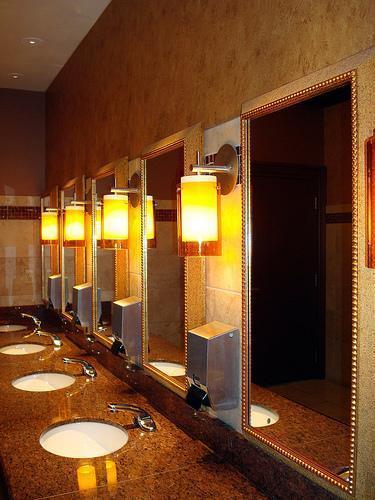How many mirrors are pictured?
Give a very brief answer. 5. How many people are in the picture?
Give a very brief answer. 0. How many sinks are shown?
Give a very brief answer. 4. 